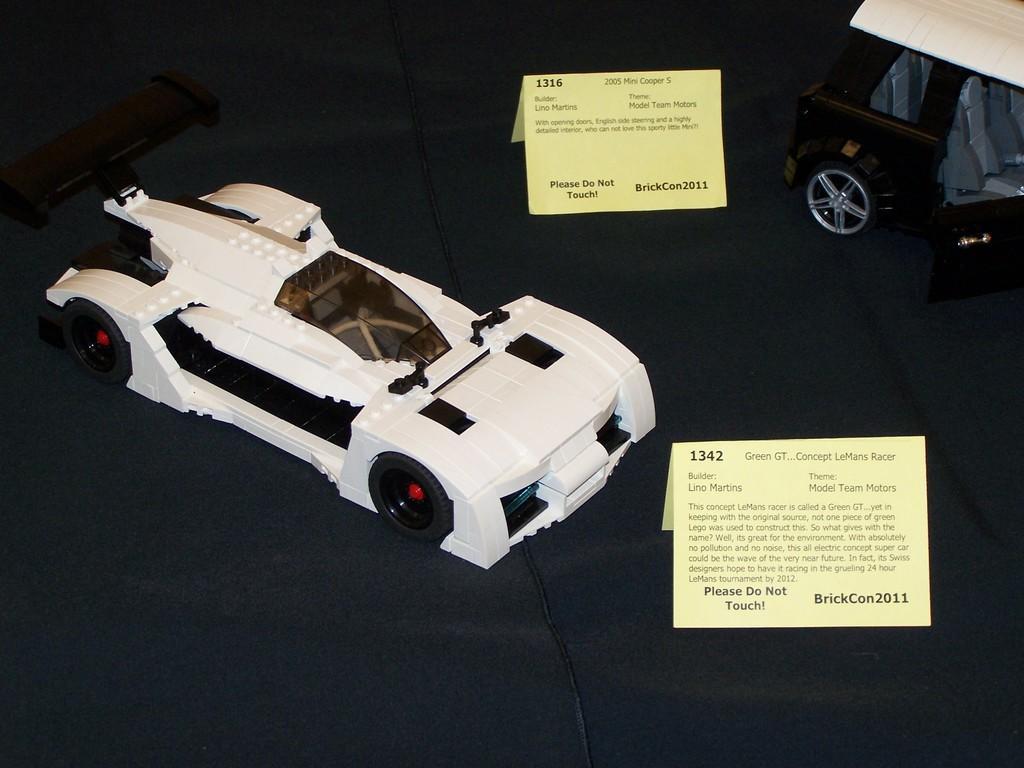Describe this image in one or two sentences. In this image I see 2 toy cars and I see 2 tabs on which there is something written and I see the wire over here. 